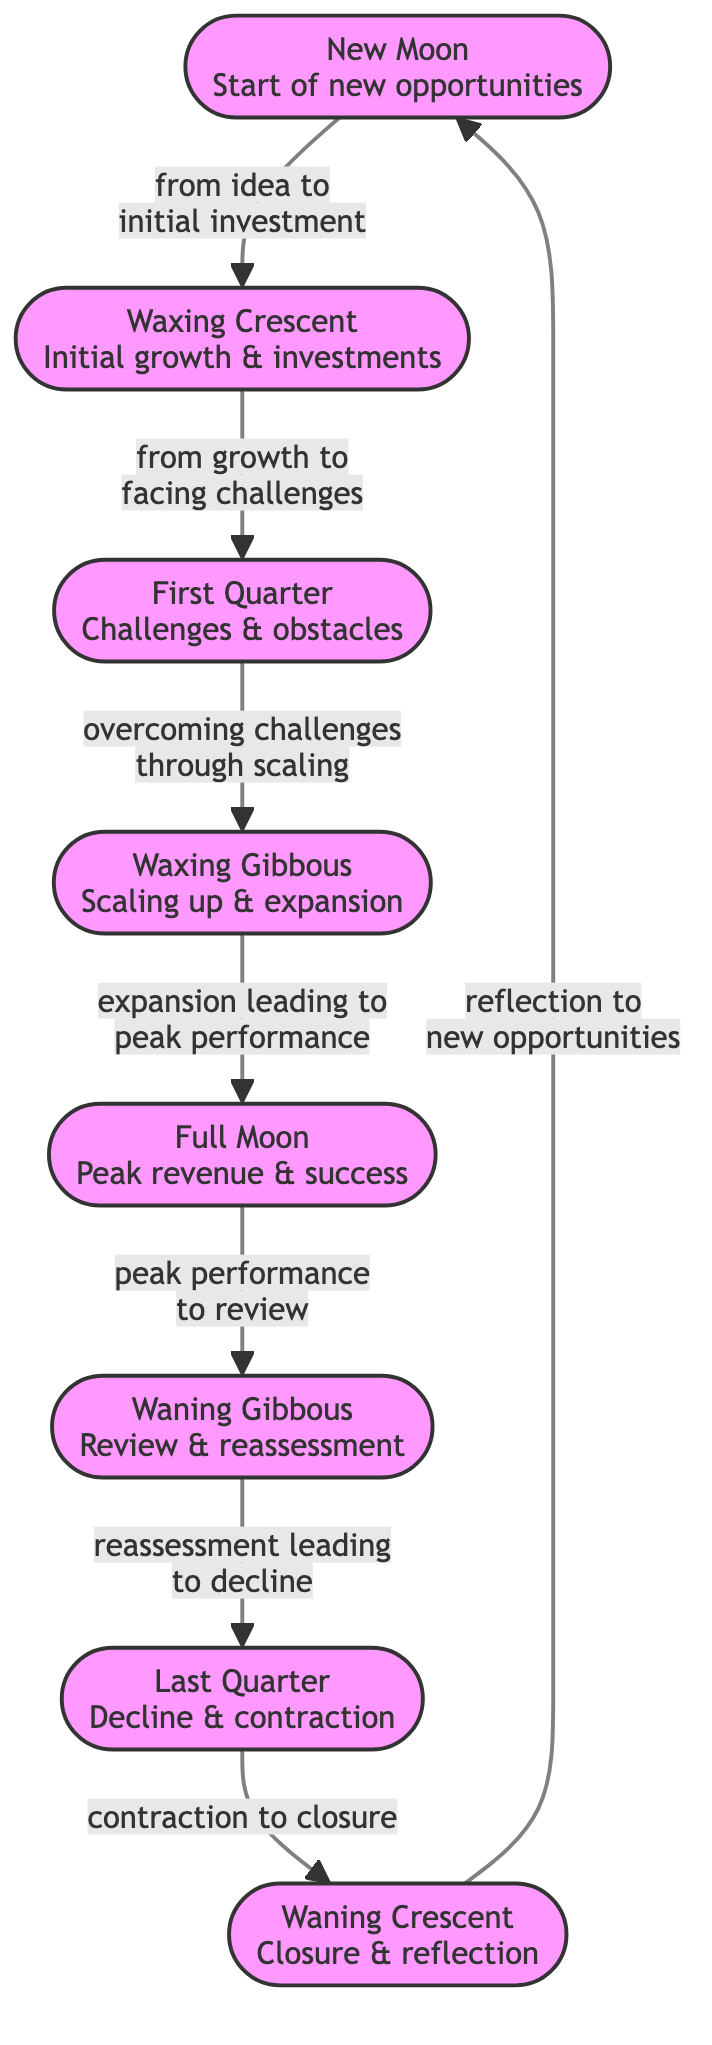What is the first phase in the revenue cycle? The first phase in the diagram is labeled "New Moon," which signifies the start of new opportunities.
Answer: New Moon What follows the "Waxing Crescent" phase? In the flow of the diagram, the "First Quarter" phase follows the "Waxing Crescent" phase.
Answer: First Quarter How many total phases are represented in the diagram? To find the total phases, we can count the nodes listed in the diagram: there are eight phases total.
Answer: Eight What is the transition from "Full Moon" to the next phase? The transition from "Full Moon" leads to the "Waning Gibbous" phase, which is characterized by review and reassessment.
Answer: Waning Gibbous Which phase signifies the peak revenue and success? The phase that signifies peak revenue and success is labeled "Full Moon."
Answer: Full Moon What phase is characterized by "closure and reflection"? "Waning Crescent" is the phase that is characterized by closure and reflection within the cycle.
Answer: Waning Crescent What happens after "Last Quarter"? Following the "Last Quarter," the diagram indicates a transition to the "Waning Crescent" phase, which emphasizes closure and reflection.
Answer: Waning Crescent Which phase represents challenges and obstacles? The phase labeled "First Quarter" represents facing challenges and obstacles as indicated in the flowchart.
Answer: First Quarter How do opportunities transition in the cycle? Opportunities transition from the "Waning Crescent" phase back to the "New Moon" phase, indicating a start of new opportunities after reflection.
Answer: New Moon 